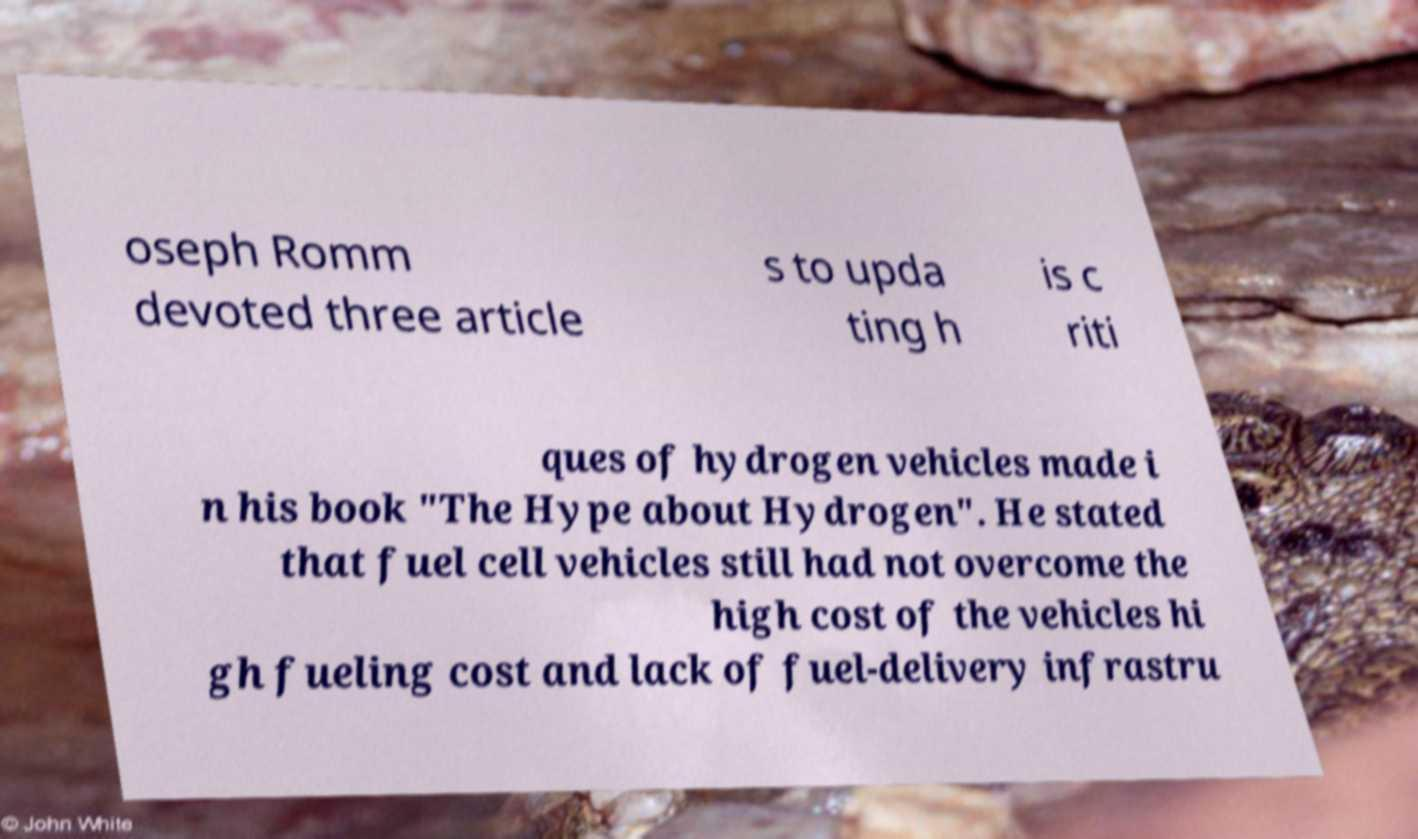Could you extract and type out the text from this image? oseph Romm devoted three article s to upda ting h is c riti ques of hydrogen vehicles made i n his book "The Hype about Hydrogen". He stated that fuel cell vehicles still had not overcome the high cost of the vehicles hi gh fueling cost and lack of fuel-delivery infrastru 